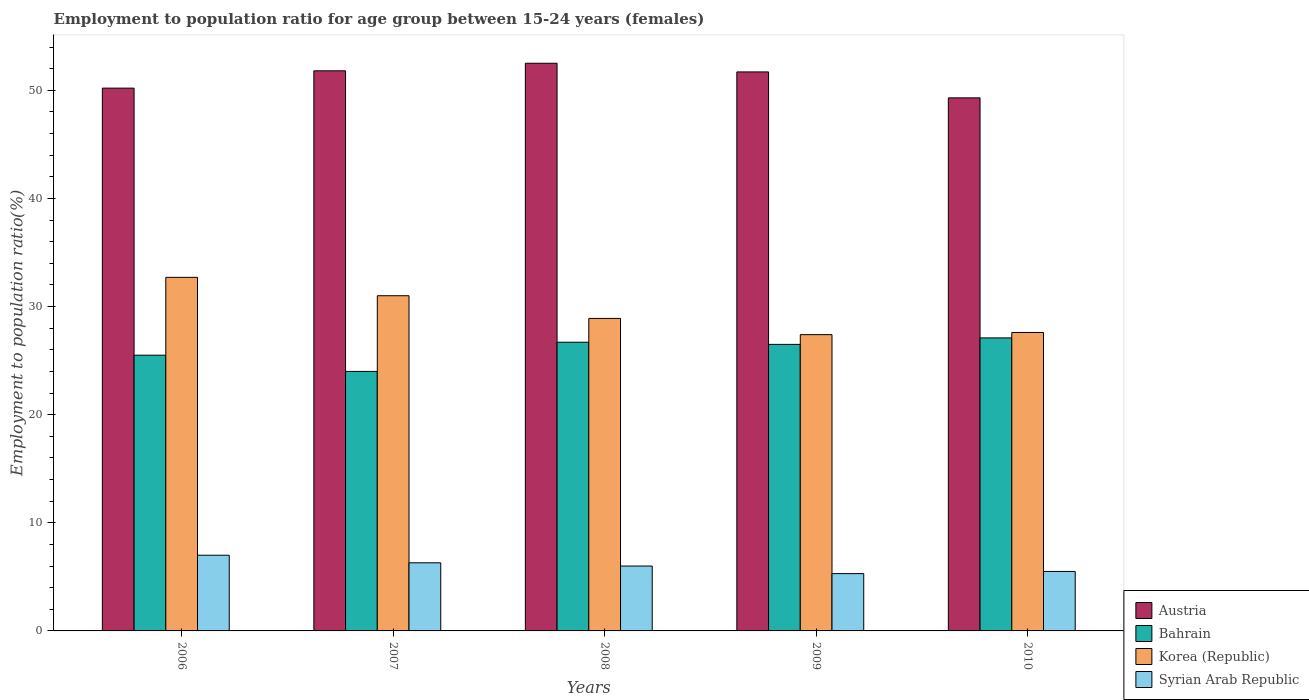Are the number of bars on each tick of the X-axis equal?
Your answer should be very brief. Yes. Across all years, what is the maximum employment to population ratio in Austria?
Make the answer very short. 52.5. Across all years, what is the minimum employment to population ratio in Korea (Republic)?
Your answer should be very brief. 27.4. In which year was the employment to population ratio in Austria maximum?
Offer a very short reply. 2008. What is the total employment to population ratio in Korea (Republic) in the graph?
Offer a very short reply. 147.6. What is the difference between the employment to population ratio in Austria in 2006 and that in 2010?
Make the answer very short. 0.9. What is the difference between the employment to population ratio in Austria in 2007 and the employment to population ratio in Syrian Arab Republic in 2006?
Provide a succinct answer. 44.8. What is the average employment to population ratio in Syrian Arab Republic per year?
Make the answer very short. 6.02. What is the ratio of the employment to population ratio in Korea (Republic) in 2009 to that in 2010?
Ensure brevity in your answer.  0.99. Is the employment to population ratio in Korea (Republic) in 2006 less than that in 2009?
Keep it short and to the point. No. Is the difference between the employment to population ratio in Bahrain in 2007 and 2009 greater than the difference between the employment to population ratio in Korea (Republic) in 2007 and 2009?
Provide a short and direct response. No. What is the difference between the highest and the second highest employment to population ratio in Austria?
Offer a very short reply. 0.7. What is the difference between the highest and the lowest employment to population ratio in Austria?
Your answer should be compact. 3.2. In how many years, is the employment to population ratio in Bahrain greater than the average employment to population ratio in Bahrain taken over all years?
Offer a terse response. 3. Is it the case that in every year, the sum of the employment to population ratio in Bahrain and employment to population ratio in Syrian Arab Republic is greater than the sum of employment to population ratio in Korea (Republic) and employment to population ratio in Austria?
Provide a succinct answer. No. What does the 3rd bar from the left in 2008 represents?
Your answer should be very brief. Korea (Republic). What does the 1st bar from the right in 2008 represents?
Give a very brief answer. Syrian Arab Republic. How many bars are there?
Your answer should be very brief. 20. How many years are there in the graph?
Make the answer very short. 5. Are the values on the major ticks of Y-axis written in scientific E-notation?
Your answer should be very brief. No. Does the graph contain grids?
Provide a short and direct response. No. Where does the legend appear in the graph?
Ensure brevity in your answer.  Bottom right. How many legend labels are there?
Ensure brevity in your answer.  4. How are the legend labels stacked?
Your answer should be very brief. Vertical. What is the title of the graph?
Your response must be concise. Employment to population ratio for age group between 15-24 years (females). What is the label or title of the Y-axis?
Give a very brief answer. Employment to population ratio(%). What is the Employment to population ratio(%) of Austria in 2006?
Your answer should be compact. 50.2. What is the Employment to population ratio(%) in Korea (Republic) in 2006?
Offer a very short reply. 32.7. What is the Employment to population ratio(%) of Syrian Arab Republic in 2006?
Offer a very short reply. 7. What is the Employment to population ratio(%) in Austria in 2007?
Keep it short and to the point. 51.8. What is the Employment to population ratio(%) in Bahrain in 2007?
Keep it short and to the point. 24. What is the Employment to population ratio(%) in Korea (Republic) in 2007?
Make the answer very short. 31. What is the Employment to population ratio(%) in Syrian Arab Republic in 2007?
Your response must be concise. 6.3. What is the Employment to population ratio(%) in Austria in 2008?
Ensure brevity in your answer.  52.5. What is the Employment to population ratio(%) in Bahrain in 2008?
Ensure brevity in your answer.  26.7. What is the Employment to population ratio(%) in Korea (Republic) in 2008?
Provide a succinct answer. 28.9. What is the Employment to population ratio(%) of Austria in 2009?
Provide a succinct answer. 51.7. What is the Employment to population ratio(%) of Bahrain in 2009?
Provide a short and direct response. 26.5. What is the Employment to population ratio(%) of Korea (Republic) in 2009?
Provide a succinct answer. 27.4. What is the Employment to population ratio(%) of Syrian Arab Republic in 2009?
Ensure brevity in your answer.  5.3. What is the Employment to population ratio(%) of Austria in 2010?
Offer a very short reply. 49.3. What is the Employment to population ratio(%) in Bahrain in 2010?
Keep it short and to the point. 27.1. What is the Employment to population ratio(%) of Korea (Republic) in 2010?
Your answer should be very brief. 27.6. What is the Employment to population ratio(%) in Syrian Arab Republic in 2010?
Your answer should be very brief. 5.5. Across all years, what is the maximum Employment to population ratio(%) in Austria?
Keep it short and to the point. 52.5. Across all years, what is the maximum Employment to population ratio(%) of Bahrain?
Your response must be concise. 27.1. Across all years, what is the maximum Employment to population ratio(%) in Korea (Republic)?
Offer a terse response. 32.7. Across all years, what is the minimum Employment to population ratio(%) of Austria?
Your answer should be compact. 49.3. Across all years, what is the minimum Employment to population ratio(%) of Korea (Republic)?
Offer a terse response. 27.4. Across all years, what is the minimum Employment to population ratio(%) of Syrian Arab Republic?
Ensure brevity in your answer.  5.3. What is the total Employment to population ratio(%) of Austria in the graph?
Your response must be concise. 255.5. What is the total Employment to population ratio(%) in Bahrain in the graph?
Provide a short and direct response. 129.8. What is the total Employment to population ratio(%) of Korea (Republic) in the graph?
Offer a terse response. 147.6. What is the total Employment to population ratio(%) in Syrian Arab Republic in the graph?
Offer a terse response. 30.1. What is the difference between the Employment to population ratio(%) of Austria in 2006 and that in 2007?
Keep it short and to the point. -1.6. What is the difference between the Employment to population ratio(%) of Korea (Republic) in 2006 and that in 2007?
Ensure brevity in your answer.  1.7. What is the difference between the Employment to population ratio(%) of Syrian Arab Republic in 2006 and that in 2007?
Make the answer very short. 0.7. What is the difference between the Employment to population ratio(%) in Bahrain in 2006 and that in 2008?
Offer a terse response. -1.2. What is the difference between the Employment to population ratio(%) in Korea (Republic) in 2006 and that in 2008?
Ensure brevity in your answer.  3.8. What is the difference between the Employment to population ratio(%) in Syrian Arab Republic in 2006 and that in 2008?
Provide a short and direct response. 1. What is the difference between the Employment to population ratio(%) of Austria in 2006 and that in 2010?
Your response must be concise. 0.9. What is the difference between the Employment to population ratio(%) in Bahrain in 2006 and that in 2010?
Ensure brevity in your answer.  -1.6. What is the difference between the Employment to population ratio(%) in Korea (Republic) in 2006 and that in 2010?
Your answer should be very brief. 5.1. What is the difference between the Employment to population ratio(%) of Bahrain in 2007 and that in 2008?
Your answer should be very brief. -2.7. What is the difference between the Employment to population ratio(%) of Syrian Arab Republic in 2007 and that in 2008?
Offer a very short reply. 0.3. What is the difference between the Employment to population ratio(%) in Austria in 2007 and that in 2009?
Ensure brevity in your answer.  0.1. What is the difference between the Employment to population ratio(%) in Bahrain in 2007 and that in 2009?
Make the answer very short. -2.5. What is the difference between the Employment to population ratio(%) of Syrian Arab Republic in 2007 and that in 2009?
Provide a short and direct response. 1. What is the difference between the Employment to population ratio(%) in Austria in 2007 and that in 2010?
Ensure brevity in your answer.  2.5. What is the difference between the Employment to population ratio(%) in Bahrain in 2007 and that in 2010?
Make the answer very short. -3.1. What is the difference between the Employment to population ratio(%) of Austria in 2008 and that in 2009?
Your answer should be compact. 0.8. What is the difference between the Employment to population ratio(%) in Syrian Arab Republic in 2008 and that in 2009?
Offer a terse response. 0.7. What is the difference between the Employment to population ratio(%) in Austria in 2008 and that in 2010?
Provide a succinct answer. 3.2. What is the difference between the Employment to population ratio(%) in Korea (Republic) in 2008 and that in 2010?
Keep it short and to the point. 1.3. What is the difference between the Employment to population ratio(%) of Syrian Arab Republic in 2008 and that in 2010?
Your answer should be very brief. 0.5. What is the difference between the Employment to population ratio(%) of Bahrain in 2009 and that in 2010?
Offer a terse response. -0.6. What is the difference between the Employment to population ratio(%) of Syrian Arab Republic in 2009 and that in 2010?
Your answer should be very brief. -0.2. What is the difference between the Employment to population ratio(%) in Austria in 2006 and the Employment to population ratio(%) in Bahrain in 2007?
Your answer should be very brief. 26.2. What is the difference between the Employment to population ratio(%) of Austria in 2006 and the Employment to population ratio(%) of Syrian Arab Republic in 2007?
Keep it short and to the point. 43.9. What is the difference between the Employment to population ratio(%) in Bahrain in 2006 and the Employment to population ratio(%) in Korea (Republic) in 2007?
Give a very brief answer. -5.5. What is the difference between the Employment to population ratio(%) in Bahrain in 2006 and the Employment to population ratio(%) in Syrian Arab Republic in 2007?
Your response must be concise. 19.2. What is the difference between the Employment to population ratio(%) in Korea (Republic) in 2006 and the Employment to population ratio(%) in Syrian Arab Republic in 2007?
Make the answer very short. 26.4. What is the difference between the Employment to population ratio(%) in Austria in 2006 and the Employment to population ratio(%) in Bahrain in 2008?
Offer a very short reply. 23.5. What is the difference between the Employment to population ratio(%) of Austria in 2006 and the Employment to population ratio(%) of Korea (Republic) in 2008?
Make the answer very short. 21.3. What is the difference between the Employment to population ratio(%) of Austria in 2006 and the Employment to population ratio(%) of Syrian Arab Republic in 2008?
Provide a succinct answer. 44.2. What is the difference between the Employment to population ratio(%) in Bahrain in 2006 and the Employment to population ratio(%) in Syrian Arab Republic in 2008?
Keep it short and to the point. 19.5. What is the difference between the Employment to population ratio(%) of Korea (Republic) in 2006 and the Employment to population ratio(%) of Syrian Arab Republic in 2008?
Provide a short and direct response. 26.7. What is the difference between the Employment to population ratio(%) of Austria in 2006 and the Employment to population ratio(%) of Bahrain in 2009?
Provide a short and direct response. 23.7. What is the difference between the Employment to population ratio(%) in Austria in 2006 and the Employment to population ratio(%) in Korea (Republic) in 2009?
Ensure brevity in your answer.  22.8. What is the difference between the Employment to population ratio(%) in Austria in 2006 and the Employment to population ratio(%) in Syrian Arab Republic in 2009?
Your answer should be very brief. 44.9. What is the difference between the Employment to population ratio(%) of Bahrain in 2006 and the Employment to population ratio(%) of Syrian Arab Republic in 2009?
Your answer should be compact. 20.2. What is the difference between the Employment to population ratio(%) of Korea (Republic) in 2006 and the Employment to population ratio(%) of Syrian Arab Republic in 2009?
Ensure brevity in your answer.  27.4. What is the difference between the Employment to population ratio(%) in Austria in 2006 and the Employment to population ratio(%) in Bahrain in 2010?
Your answer should be very brief. 23.1. What is the difference between the Employment to population ratio(%) of Austria in 2006 and the Employment to population ratio(%) of Korea (Republic) in 2010?
Your response must be concise. 22.6. What is the difference between the Employment to population ratio(%) of Austria in 2006 and the Employment to population ratio(%) of Syrian Arab Republic in 2010?
Give a very brief answer. 44.7. What is the difference between the Employment to population ratio(%) of Bahrain in 2006 and the Employment to population ratio(%) of Syrian Arab Republic in 2010?
Offer a terse response. 20. What is the difference between the Employment to population ratio(%) of Korea (Republic) in 2006 and the Employment to population ratio(%) of Syrian Arab Republic in 2010?
Your answer should be very brief. 27.2. What is the difference between the Employment to population ratio(%) in Austria in 2007 and the Employment to population ratio(%) in Bahrain in 2008?
Your response must be concise. 25.1. What is the difference between the Employment to population ratio(%) in Austria in 2007 and the Employment to population ratio(%) in Korea (Republic) in 2008?
Offer a terse response. 22.9. What is the difference between the Employment to population ratio(%) of Austria in 2007 and the Employment to population ratio(%) of Syrian Arab Republic in 2008?
Keep it short and to the point. 45.8. What is the difference between the Employment to population ratio(%) of Bahrain in 2007 and the Employment to population ratio(%) of Korea (Republic) in 2008?
Make the answer very short. -4.9. What is the difference between the Employment to population ratio(%) in Bahrain in 2007 and the Employment to population ratio(%) in Syrian Arab Republic in 2008?
Give a very brief answer. 18. What is the difference between the Employment to population ratio(%) in Austria in 2007 and the Employment to population ratio(%) in Bahrain in 2009?
Your response must be concise. 25.3. What is the difference between the Employment to population ratio(%) of Austria in 2007 and the Employment to population ratio(%) of Korea (Republic) in 2009?
Provide a short and direct response. 24.4. What is the difference between the Employment to population ratio(%) of Austria in 2007 and the Employment to population ratio(%) of Syrian Arab Republic in 2009?
Give a very brief answer. 46.5. What is the difference between the Employment to population ratio(%) in Bahrain in 2007 and the Employment to population ratio(%) in Korea (Republic) in 2009?
Your answer should be compact. -3.4. What is the difference between the Employment to population ratio(%) of Bahrain in 2007 and the Employment to population ratio(%) of Syrian Arab Republic in 2009?
Ensure brevity in your answer.  18.7. What is the difference between the Employment to population ratio(%) in Korea (Republic) in 2007 and the Employment to population ratio(%) in Syrian Arab Republic in 2009?
Ensure brevity in your answer.  25.7. What is the difference between the Employment to population ratio(%) in Austria in 2007 and the Employment to population ratio(%) in Bahrain in 2010?
Your answer should be compact. 24.7. What is the difference between the Employment to population ratio(%) in Austria in 2007 and the Employment to population ratio(%) in Korea (Republic) in 2010?
Offer a very short reply. 24.2. What is the difference between the Employment to population ratio(%) in Austria in 2007 and the Employment to population ratio(%) in Syrian Arab Republic in 2010?
Make the answer very short. 46.3. What is the difference between the Employment to population ratio(%) of Korea (Republic) in 2007 and the Employment to population ratio(%) of Syrian Arab Republic in 2010?
Your answer should be very brief. 25.5. What is the difference between the Employment to population ratio(%) in Austria in 2008 and the Employment to population ratio(%) in Korea (Republic) in 2009?
Your answer should be compact. 25.1. What is the difference between the Employment to population ratio(%) in Austria in 2008 and the Employment to population ratio(%) in Syrian Arab Republic in 2009?
Offer a very short reply. 47.2. What is the difference between the Employment to population ratio(%) in Bahrain in 2008 and the Employment to population ratio(%) in Korea (Republic) in 2009?
Provide a short and direct response. -0.7. What is the difference between the Employment to population ratio(%) of Bahrain in 2008 and the Employment to population ratio(%) of Syrian Arab Republic in 2009?
Provide a short and direct response. 21.4. What is the difference between the Employment to population ratio(%) in Korea (Republic) in 2008 and the Employment to population ratio(%) in Syrian Arab Republic in 2009?
Make the answer very short. 23.6. What is the difference between the Employment to population ratio(%) of Austria in 2008 and the Employment to population ratio(%) of Bahrain in 2010?
Make the answer very short. 25.4. What is the difference between the Employment to population ratio(%) in Austria in 2008 and the Employment to population ratio(%) in Korea (Republic) in 2010?
Offer a terse response. 24.9. What is the difference between the Employment to population ratio(%) of Bahrain in 2008 and the Employment to population ratio(%) of Korea (Republic) in 2010?
Provide a short and direct response. -0.9. What is the difference between the Employment to population ratio(%) in Bahrain in 2008 and the Employment to population ratio(%) in Syrian Arab Republic in 2010?
Keep it short and to the point. 21.2. What is the difference between the Employment to population ratio(%) of Korea (Republic) in 2008 and the Employment to population ratio(%) of Syrian Arab Republic in 2010?
Give a very brief answer. 23.4. What is the difference between the Employment to population ratio(%) of Austria in 2009 and the Employment to population ratio(%) of Bahrain in 2010?
Your answer should be very brief. 24.6. What is the difference between the Employment to population ratio(%) in Austria in 2009 and the Employment to population ratio(%) in Korea (Republic) in 2010?
Offer a terse response. 24.1. What is the difference between the Employment to population ratio(%) of Austria in 2009 and the Employment to population ratio(%) of Syrian Arab Republic in 2010?
Ensure brevity in your answer.  46.2. What is the difference between the Employment to population ratio(%) in Korea (Republic) in 2009 and the Employment to population ratio(%) in Syrian Arab Republic in 2010?
Make the answer very short. 21.9. What is the average Employment to population ratio(%) in Austria per year?
Offer a terse response. 51.1. What is the average Employment to population ratio(%) of Bahrain per year?
Your answer should be compact. 25.96. What is the average Employment to population ratio(%) of Korea (Republic) per year?
Offer a terse response. 29.52. What is the average Employment to population ratio(%) in Syrian Arab Republic per year?
Your answer should be very brief. 6.02. In the year 2006, what is the difference between the Employment to population ratio(%) in Austria and Employment to population ratio(%) in Bahrain?
Offer a very short reply. 24.7. In the year 2006, what is the difference between the Employment to population ratio(%) in Austria and Employment to population ratio(%) in Korea (Republic)?
Your answer should be very brief. 17.5. In the year 2006, what is the difference between the Employment to population ratio(%) of Austria and Employment to population ratio(%) of Syrian Arab Republic?
Ensure brevity in your answer.  43.2. In the year 2006, what is the difference between the Employment to population ratio(%) of Korea (Republic) and Employment to population ratio(%) of Syrian Arab Republic?
Your answer should be very brief. 25.7. In the year 2007, what is the difference between the Employment to population ratio(%) of Austria and Employment to population ratio(%) of Bahrain?
Your answer should be compact. 27.8. In the year 2007, what is the difference between the Employment to population ratio(%) in Austria and Employment to population ratio(%) in Korea (Republic)?
Make the answer very short. 20.8. In the year 2007, what is the difference between the Employment to population ratio(%) in Austria and Employment to population ratio(%) in Syrian Arab Republic?
Your answer should be very brief. 45.5. In the year 2007, what is the difference between the Employment to population ratio(%) in Bahrain and Employment to population ratio(%) in Syrian Arab Republic?
Ensure brevity in your answer.  17.7. In the year 2007, what is the difference between the Employment to population ratio(%) of Korea (Republic) and Employment to population ratio(%) of Syrian Arab Republic?
Your answer should be compact. 24.7. In the year 2008, what is the difference between the Employment to population ratio(%) of Austria and Employment to population ratio(%) of Bahrain?
Your answer should be very brief. 25.8. In the year 2008, what is the difference between the Employment to population ratio(%) of Austria and Employment to population ratio(%) of Korea (Republic)?
Keep it short and to the point. 23.6. In the year 2008, what is the difference between the Employment to population ratio(%) of Austria and Employment to population ratio(%) of Syrian Arab Republic?
Offer a very short reply. 46.5. In the year 2008, what is the difference between the Employment to population ratio(%) of Bahrain and Employment to population ratio(%) of Korea (Republic)?
Offer a terse response. -2.2. In the year 2008, what is the difference between the Employment to population ratio(%) of Bahrain and Employment to population ratio(%) of Syrian Arab Republic?
Your answer should be very brief. 20.7. In the year 2008, what is the difference between the Employment to population ratio(%) of Korea (Republic) and Employment to population ratio(%) of Syrian Arab Republic?
Offer a terse response. 22.9. In the year 2009, what is the difference between the Employment to population ratio(%) in Austria and Employment to population ratio(%) in Bahrain?
Offer a terse response. 25.2. In the year 2009, what is the difference between the Employment to population ratio(%) of Austria and Employment to population ratio(%) of Korea (Republic)?
Your answer should be compact. 24.3. In the year 2009, what is the difference between the Employment to population ratio(%) in Austria and Employment to population ratio(%) in Syrian Arab Republic?
Provide a succinct answer. 46.4. In the year 2009, what is the difference between the Employment to population ratio(%) in Bahrain and Employment to population ratio(%) in Korea (Republic)?
Your response must be concise. -0.9. In the year 2009, what is the difference between the Employment to population ratio(%) of Bahrain and Employment to population ratio(%) of Syrian Arab Republic?
Make the answer very short. 21.2. In the year 2009, what is the difference between the Employment to population ratio(%) of Korea (Republic) and Employment to population ratio(%) of Syrian Arab Republic?
Give a very brief answer. 22.1. In the year 2010, what is the difference between the Employment to population ratio(%) in Austria and Employment to population ratio(%) in Bahrain?
Ensure brevity in your answer.  22.2. In the year 2010, what is the difference between the Employment to population ratio(%) in Austria and Employment to population ratio(%) in Korea (Republic)?
Your answer should be very brief. 21.7. In the year 2010, what is the difference between the Employment to population ratio(%) in Austria and Employment to population ratio(%) in Syrian Arab Republic?
Give a very brief answer. 43.8. In the year 2010, what is the difference between the Employment to population ratio(%) of Bahrain and Employment to population ratio(%) of Syrian Arab Republic?
Your answer should be compact. 21.6. In the year 2010, what is the difference between the Employment to population ratio(%) of Korea (Republic) and Employment to population ratio(%) of Syrian Arab Republic?
Keep it short and to the point. 22.1. What is the ratio of the Employment to population ratio(%) of Austria in 2006 to that in 2007?
Your answer should be very brief. 0.97. What is the ratio of the Employment to population ratio(%) of Korea (Republic) in 2006 to that in 2007?
Keep it short and to the point. 1.05. What is the ratio of the Employment to population ratio(%) of Austria in 2006 to that in 2008?
Offer a terse response. 0.96. What is the ratio of the Employment to population ratio(%) of Bahrain in 2006 to that in 2008?
Provide a succinct answer. 0.96. What is the ratio of the Employment to population ratio(%) in Korea (Republic) in 2006 to that in 2008?
Your answer should be very brief. 1.13. What is the ratio of the Employment to population ratio(%) in Bahrain in 2006 to that in 2009?
Your answer should be very brief. 0.96. What is the ratio of the Employment to population ratio(%) in Korea (Republic) in 2006 to that in 2009?
Make the answer very short. 1.19. What is the ratio of the Employment to population ratio(%) in Syrian Arab Republic in 2006 to that in 2009?
Your response must be concise. 1.32. What is the ratio of the Employment to population ratio(%) in Austria in 2006 to that in 2010?
Your answer should be very brief. 1.02. What is the ratio of the Employment to population ratio(%) of Bahrain in 2006 to that in 2010?
Your response must be concise. 0.94. What is the ratio of the Employment to population ratio(%) of Korea (Republic) in 2006 to that in 2010?
Ensure brevity in your answer.  1.18. What is the ratio of the Employment to population ratio(%) of Syrian Arab Republic in 2006 to that in 2010?
Keep it short and to the point. 1.27. What is the ratio of the Employment to population ratio(%) of Austria in 2007 to that in 2008?
Give a very brief answer. 0.99. What is the ratio of the Employment to population ratio(%) in Bahrain in 2007 to that in 2008?
Keep it short and to the point. 0.9. What is the ratio of the Employment to population ratio(%) in Korea (Republic) in 2007 to that in 2008?
Your response must be concise. 1.07. What is the ratio of the Employment to population ratio(%) of Austria in 2007 to that in 2009?
Your response must be concise. 1. What is the ratio of the Employment to population ratio(%) of Bahrain in 2007 to that in 2009?
Provide a short and direct response. 0.91. What is the ratio of the Employment to population ratio(%) of Korea (Republic) in 2007 to that in 2009?
Make the answer very short. 1.13. What is the ratio of the Employment to population ratio(%) of Syrian Arab Republic in 2007 to that in 2009?
Offer a very short reply. 1.19. What is the ratio of the Employment to population ratio(%) of Austria in 2007 to that in 2010?
Offer a very short reply. 1.05. What is the ratio of the Employment to population ratio(%) in Bahrain in 2007 to that in 2010?
Your answer should be compact. 0.89. What is the ratio of the Employment to population ratio(%) of Korea (Republic) in 2007 to that in 2010?
Give a very brief answer. 1.12. What is the ratio of the Employment to population ratio(%) in Syrian Arab Republic in 2007 to that in 2010?
Your response must be concise. 1.15. What is the ratio of the Employment to population ratio(%) of Austria in 2008 to that in 2009?
Provide a short and direct response. 1.02. What is the ratio of the Employment to population ratio(%) of Bahrain in 2008 to that in 2009?
Give a very brief answer. 1.01. What is the ratio of the Employment to population ratio(%) of Korea (Republic) in 2008 to that in 2009?
Your response must be concise. 1.05. What is the ratio of the Employment to population ratio(%) of Syrian Arab Republic in 2008 to that in 2009?
Provide a succinct answer. 1.13. What is the ratio of the Employment to population ratio(%) in Austria in 2008 to that in 2010?
Ensure brevity in your answer.  1.06. What is the ratio of the Employment to population ratio(%) of Bahrain in 2008 to that in 2010?
Your answer should be compact. 0.99. What is the ratio of the Employment to population ratio(%) in Korea (Republic) in 2008 to that in 2010?
Give a very brief answer. 1.05. What is the ratio of the Employment to population ratio(%) in Austria in 2009 to that in 2010?
Provide a short and direct response. 1.05. What is the ratio of the Employment to population ratio(%) in Bahrain in 2009 to that in 2010?
Keep it short and to the point. 0.98. What is the ratio of the Employment to population ratio(%) in Korea (Republic) in 2009 to that in 2010?
Provide a short and direct response. 0.99. What is the ratio of the Employment to population ratio(%) in Syrian Arab Republic in 2009 to that in 2010?
Give a very brief answer. 0.96. What is the difference between the highest and the second highest Employment to population ratio(%) in Korea (Republic)?
Give a very brief answer. 1.7. What is the difference between the highest and the second highest Employment to population ratio(%) of Syrian Arab Republic?
Give a very brief answer. 0.7. What is the difference between the highest and the lowest Employment to population ratio(%) of Bahrain?
Provide a short and direct response. 3.1. What is the difference between the highest and the lowest Employment to population ratio(%) of Korea (Republic)?
Your response must be concise. 5.3. What is the difference between the highest and the lowest Employment to population ratio(%) in Syrian Arab Republic?
Your response must be concise. 1.7. 